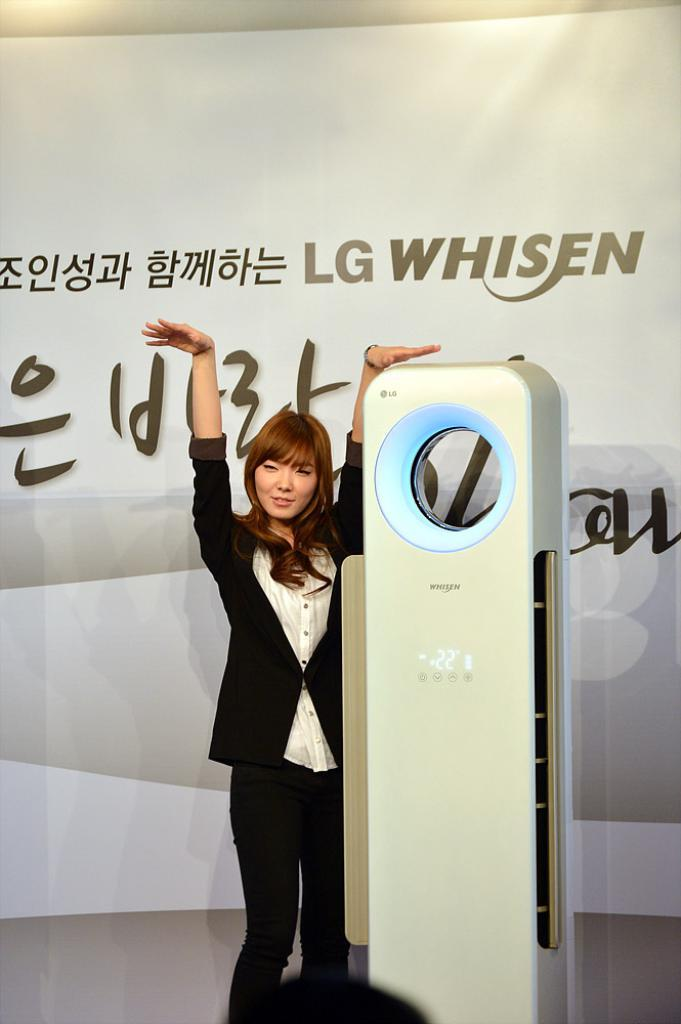Who is the main subject in the image? There is a lady in the image. What is the lady wearing? The lady is wearing a black suit. What can be seen beside the lady in the image? The lady is standing beside an electronic machine. What is visible in the background of the image? There is a banner in the background of the image. How many grapes are hanging from the lady's suit in the image? There are no grapes present in the image, and therefore none can be seen hanging from the lady's suit. 